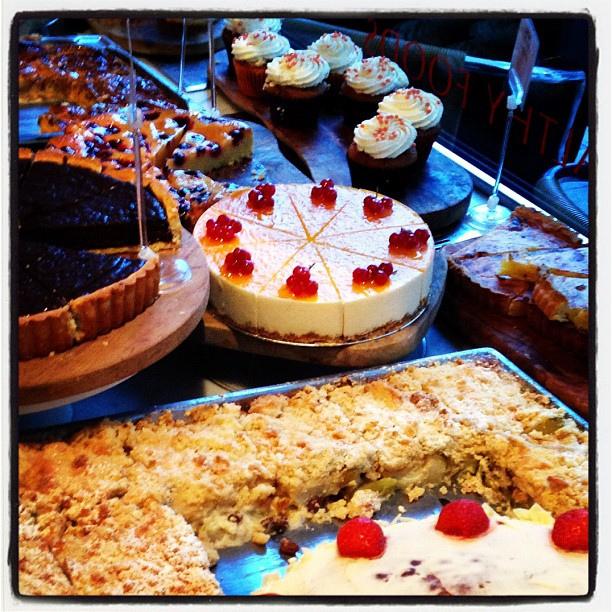What dish is on the table?
Be succinct. Cheesecake. Is all the cake there?
Write a very short answer. No. Is this the kind of food you would eat for dessert?
Concise answer only. Yes. How many pieces is the cake cut into?
Quick response, please. 8. 